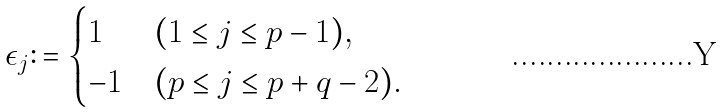Convert formula to latex. <formula><loc_0><loc_0><loc_500><loc_500>\epsilon _ { j } \colon = \begin{cases} 1 & ( 1 \leq j \leq p - 1 ) , \\ - 1 & ( p \leq j \leq p + q - 2 ) . \end{cases}</formula> 